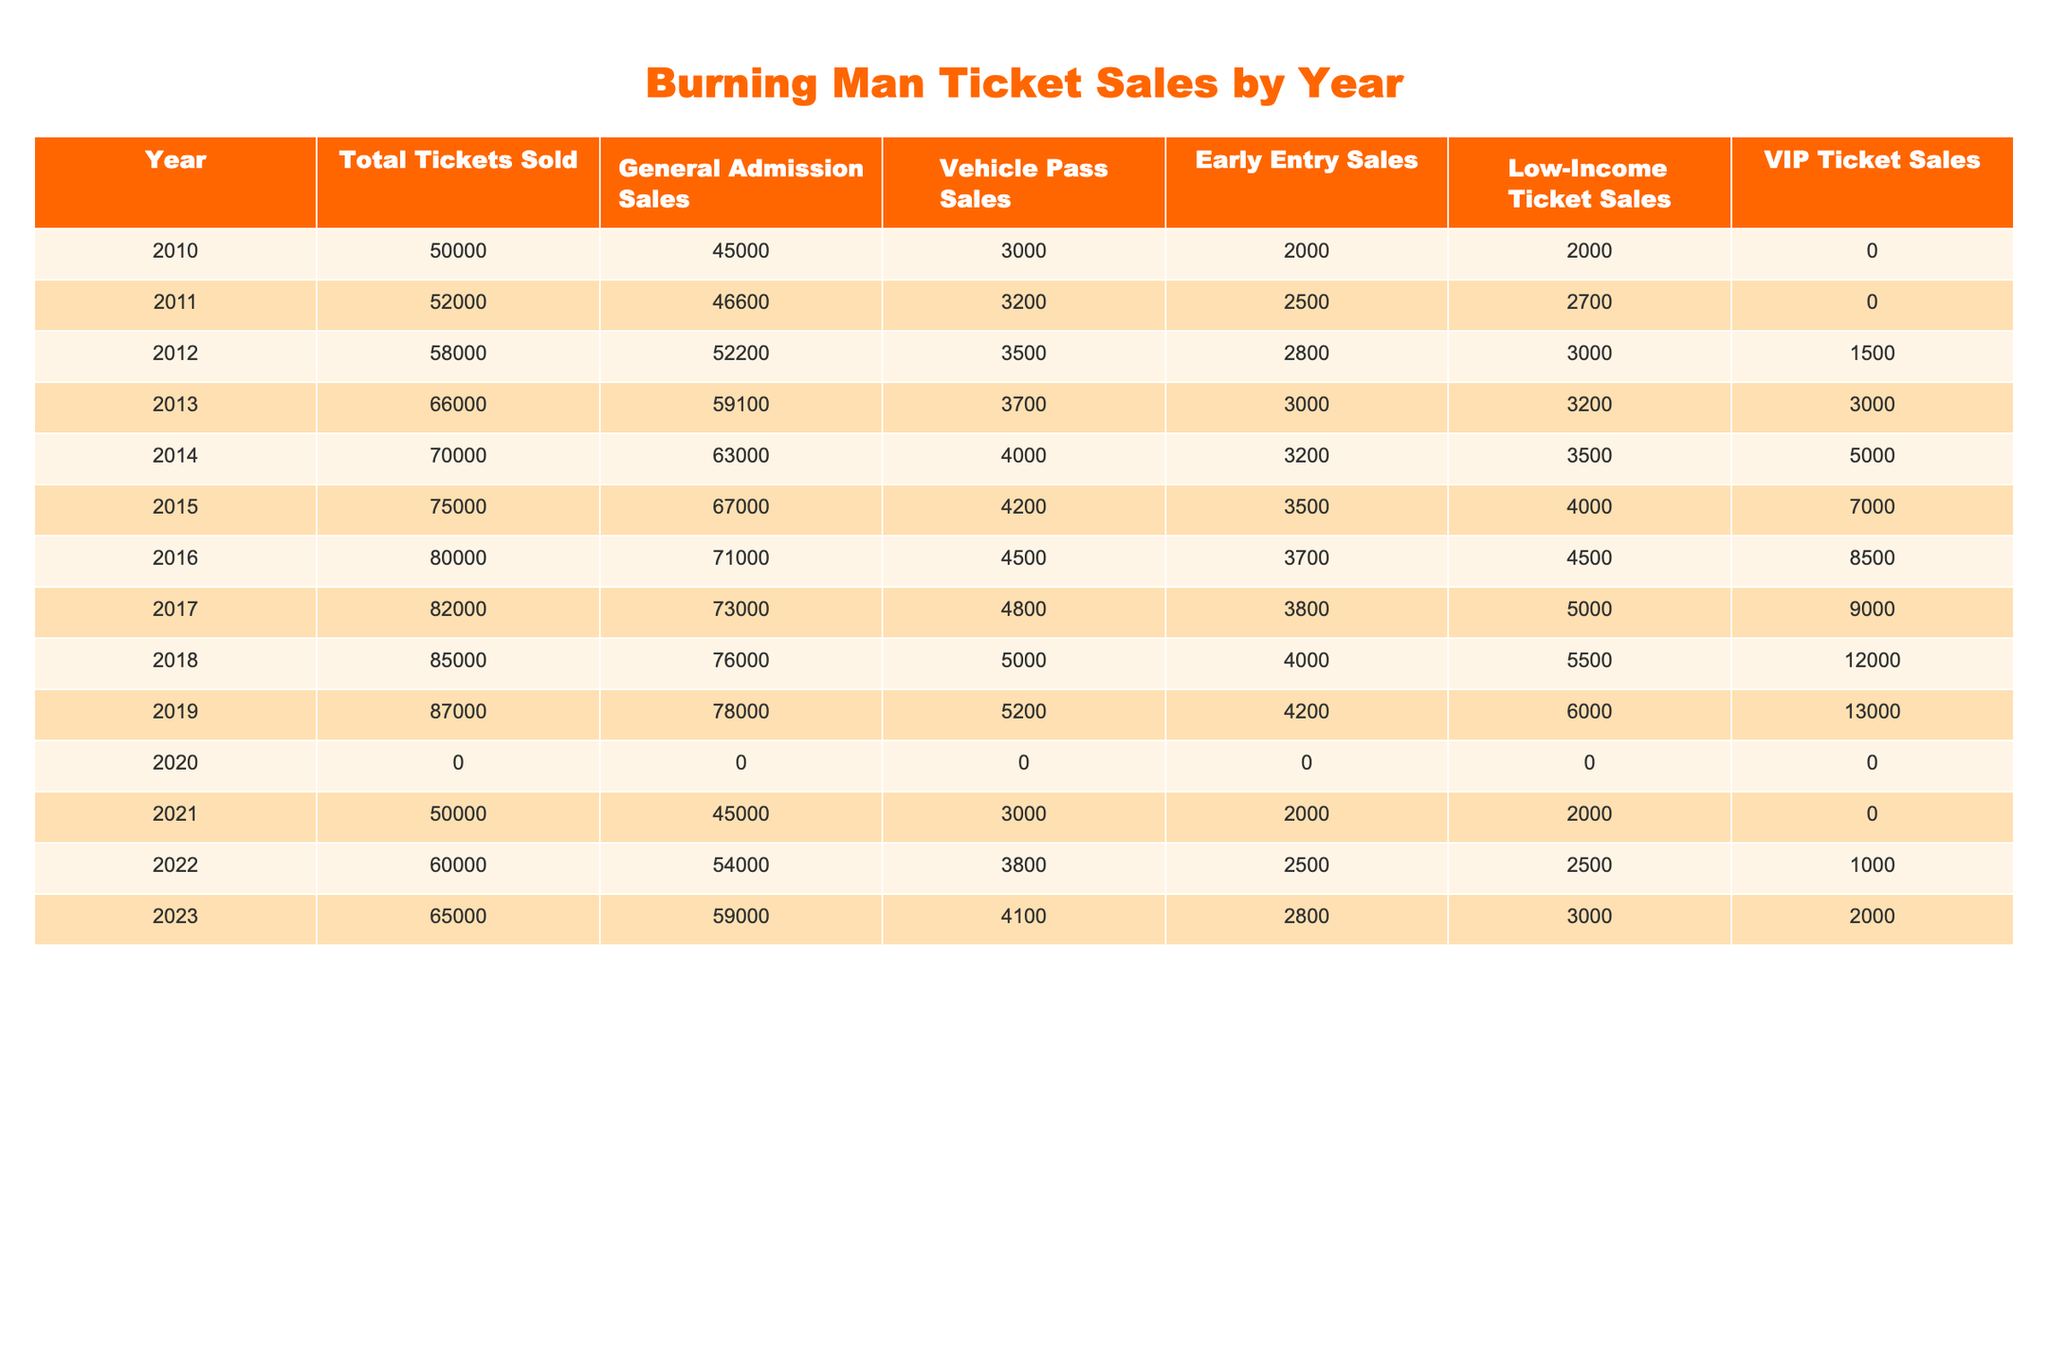What was the total ticket sales in 2016? The total tickets sold for the year 2016 is specifically noted in the table as 80000.
Answer: 80000 Which year had the highest number of Low-Income Ticket Sales? Looking through the Low-Income Ticket Sales column, the highest number is 13000, which occurred in 2019.
Answer: 2019 How many more General Admission Tickets were sold in 2019 compared to 2011? For 2019, the General Admission sales are 78000, and for 2011, they are 46600. Subtracting these gives 78000 - 46600 = 31400.
Answer: 31400 Was there a decline in total ticket sales from 2019 to 2020? In 2019, total ticket sales were 87000, and in 2020, they were 0. Since 0 is less than 87000, there was a decline.
Answer: Yes What is the median number of Vehicle Pass Sales across all years? The Vehicle Pass Sales data points across years are: 3000, 3200, 3500, 3700, 4000, 4200, 4500, 4800, 5000, 5200, 0, 3000, 3800, 4100. Arranging these gives: 0, 3000, 3000, 3200, 3500, 3700, 3800, 4000, 4100, 4200, 4500, 4800, 5000, 5200. The median falls between the 7th and 8th values (3800 and 4000), averaging to (3800 + 4000) / 2 = 3900.
Answer: 3900 How much did Early Entry Sales increase from 2010 to 2018? In 2010, Early Entry Sales were 2000, and in 2018, they were 4000. The difference is 4000 - 2000 = 2000.
Answer: 2000 In which year did total ticket sales first exceed 60000? By examining the Total Tickets Sold column, the first occurrence where sales exceeded 60000 is the year 2014, with sales at 70000.
Answer: 2014 What was the average number of VIP Ticket Sales from 2011 to 2015? To find the average, sum the VIP Ticket Sales for 2011 (0), 2012 (1500), 2013 (3000), 2014 (5000), and 2015 (7000). Calculating gives: 0 + 1500 + 3000 + 5000 + 7000 = 16500. Dividing by 5 results in an average of 16500 / 5 = 3300.
Answer: 3300 Was 2021 a better year for total ticket sales than 2020? The total ticket sales for 2021 were 50000 while for 2020 it was 0. Since 50000 is greater than 0, 2021 was indeed better.
Answer: Yes 